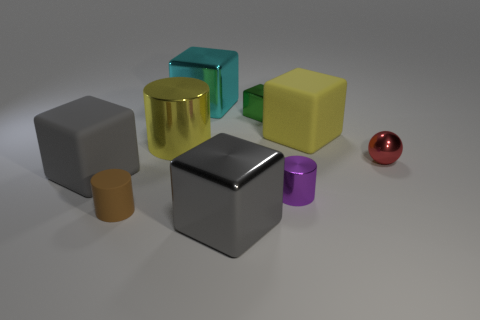Subtract 1 cubes. How many cubes are left? 4 Subtract all large yellow rubber cubes. How many cubes are left? 4 Subtract all cyan blocks. How many blocks are left? 4 Subtract all blue blocks. Subtract all red cylinders. How many blocks are left? 5 Add 1 large gray metallic things. How many objects exist? 10 Subtract all blocks. How many objects are left? 4 Add 9 gray metal objects. How many gray metal objects are left? 10 Add 8 large balls. How many large balls exist? 8 Subtract 0 purple blocks. How many objects are left? 9 Subtract all green blocks. Subtract all red shiny balls. How many objects are left? 7 